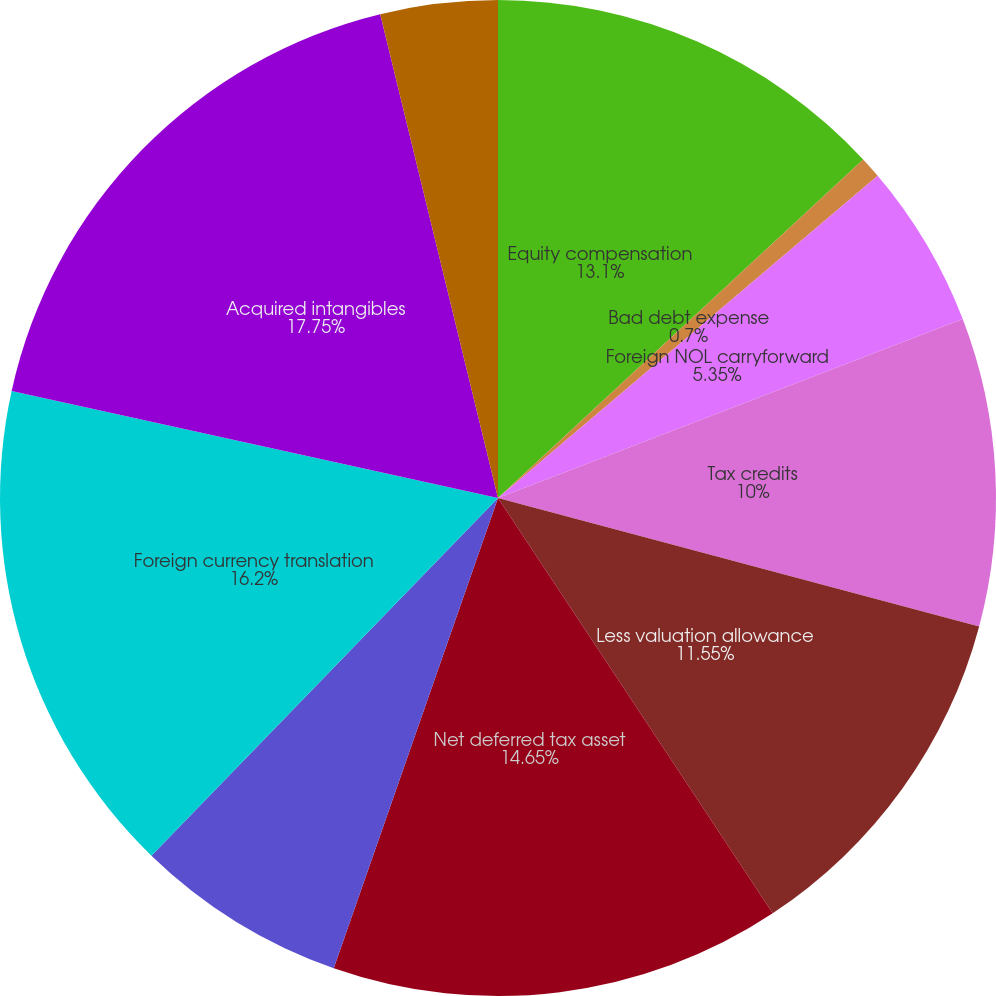<chart> <loc_0><loc_0><loc_500><loc_500><pie_chart><fcel>Equity compensation<fcel>Bad debt expense<fcel>Foreign NOL carryforward<fcel>Tax credits<fcel>Less valuation allowance<fcel>Net deferred tax asset<fcel>Accrued expenses and other<fcel>Foreign currency translation<fcel>Acquired intangibles<fcel>Prepaid expenses<nl><fcel>13.1%<fcel>0.7%<fcel>5.35%<fcel>10.0%<fcel>11.55%<fcel>14.65%<fcel>6.9%<fcel>16.2%<fcel>17.75%<fcel>3.8%<nl></chart> 